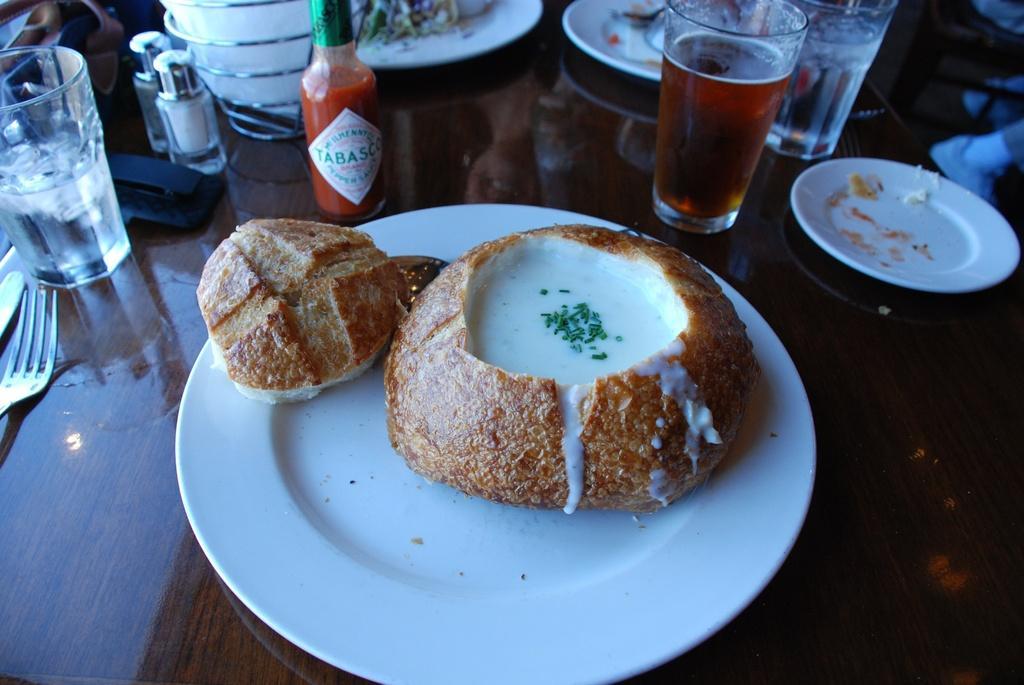In one or two sentences, can you explain what this image depicts? In the image we can see the wooden surface, on it we can see white plates, in the white plates we can see food items. Here we can see fork, glasses, bottles and other things. 